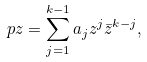Convert formula to latex. <formula><loc_0><loc_0><loc_500><loc_500>\ p z = \sum _ { j = 1 } ^ { k - 1 } a _ { j } z ^ { j } \bar { z } ^ { k - j } , \</formula> 